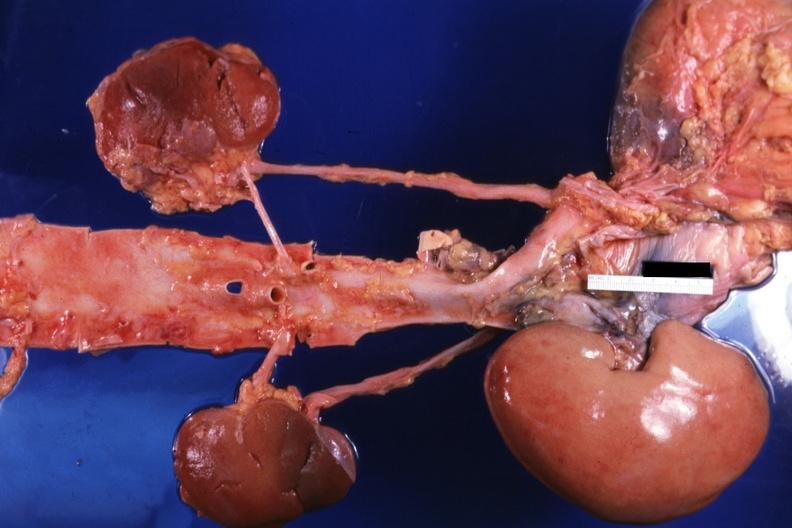what is the transplant placed?
Answer the question using a single word or phrase. Placed relative to other structures 